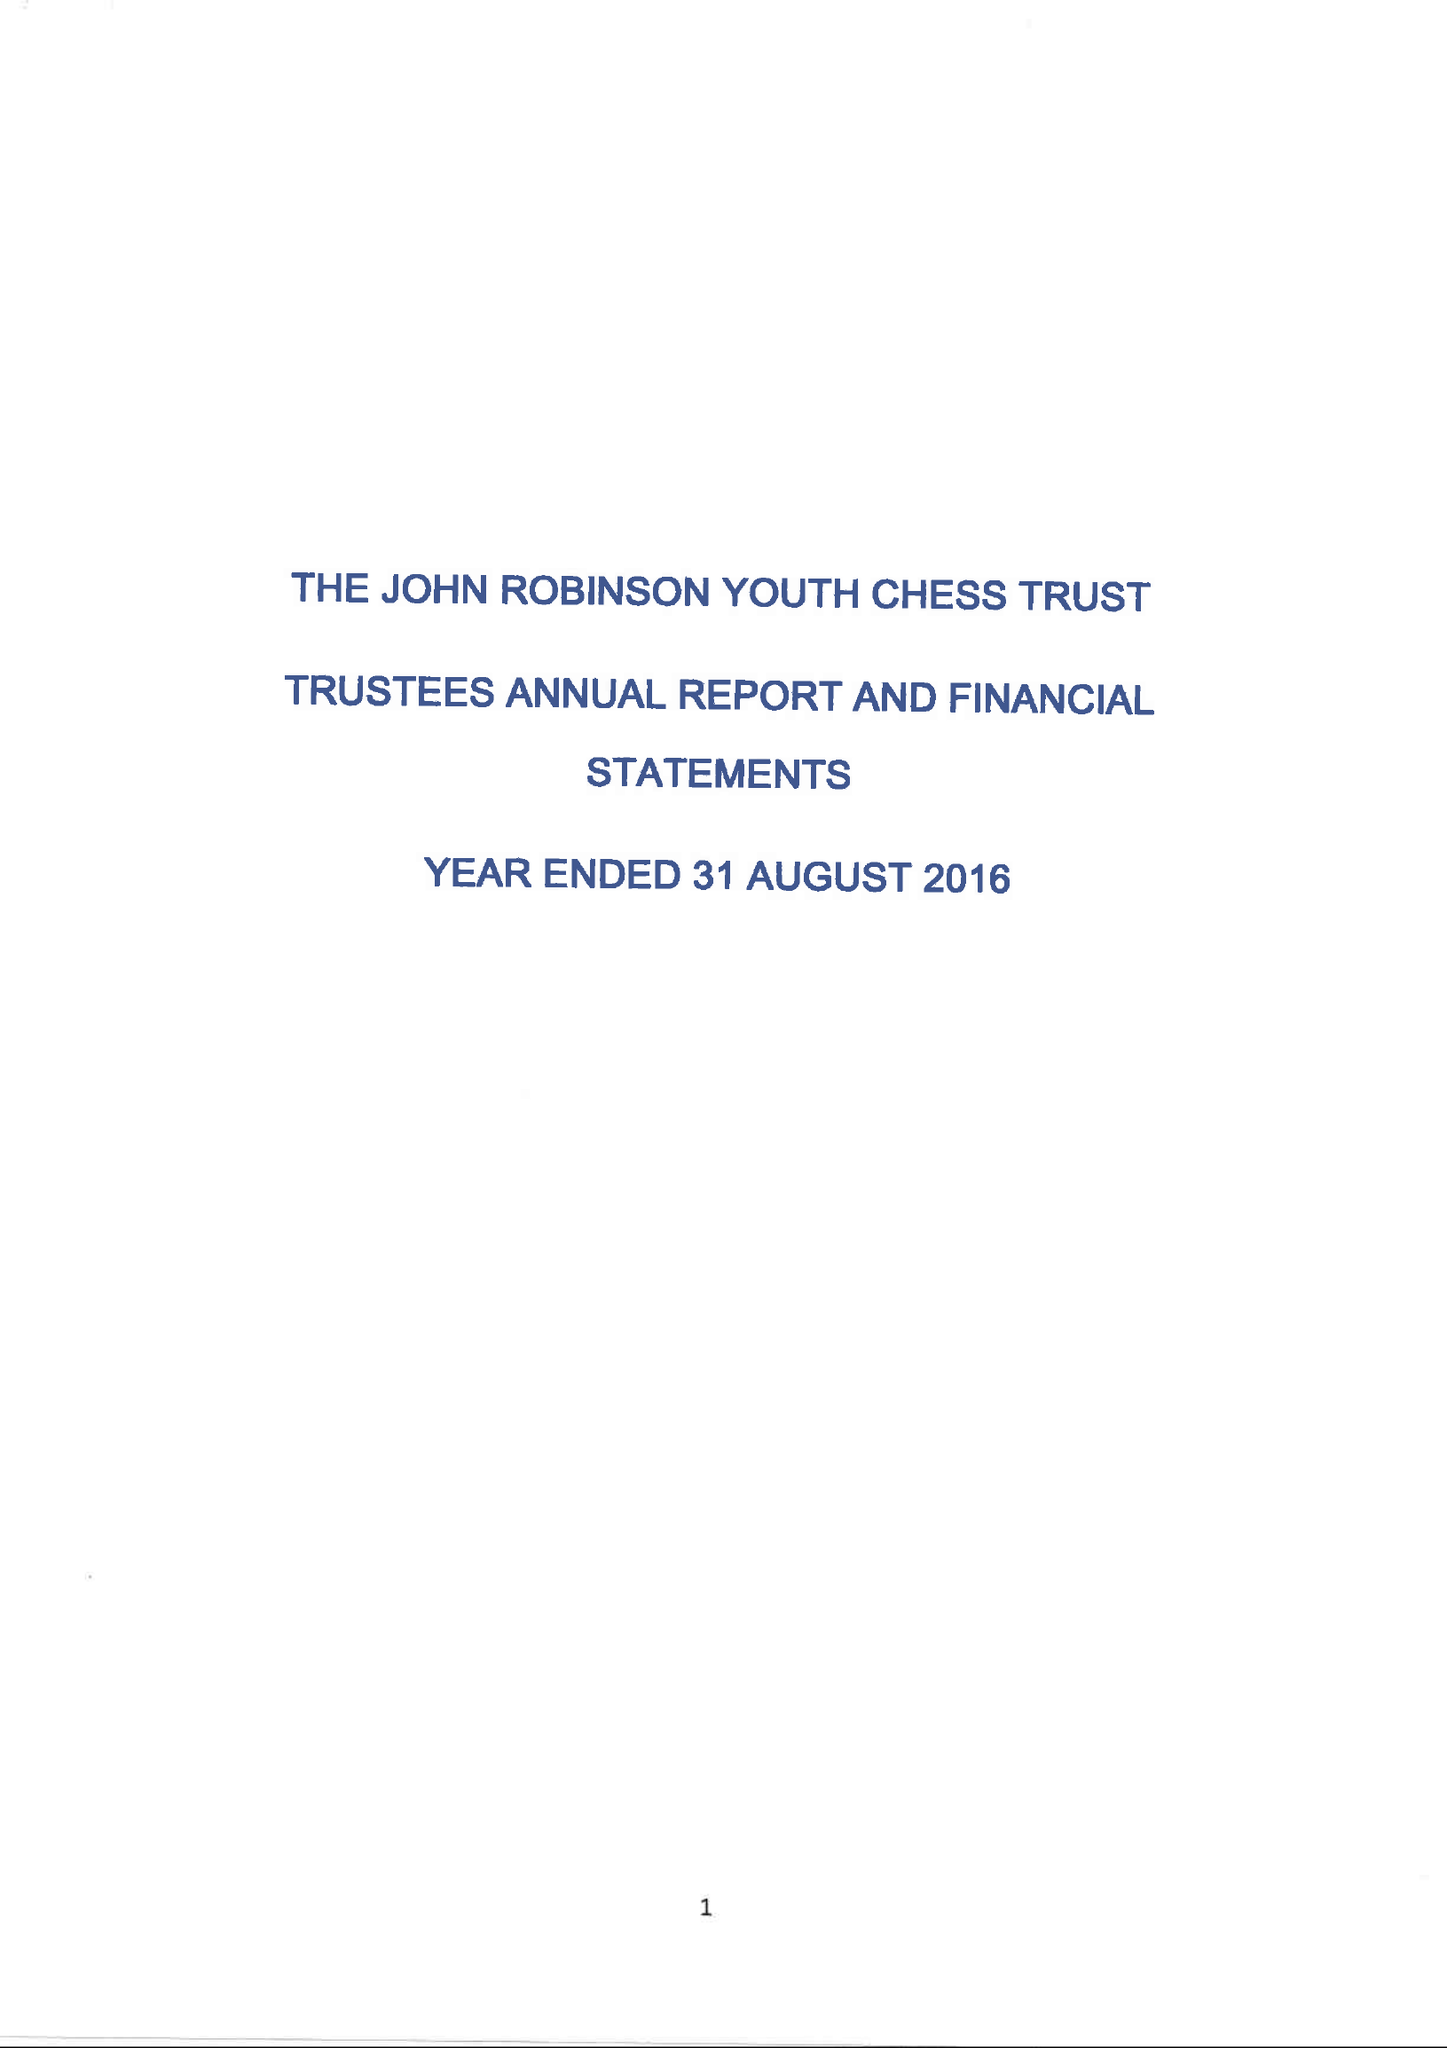What is the value for the address__postcode?
Answer the question using a single word or phrase. RH10 7FT 